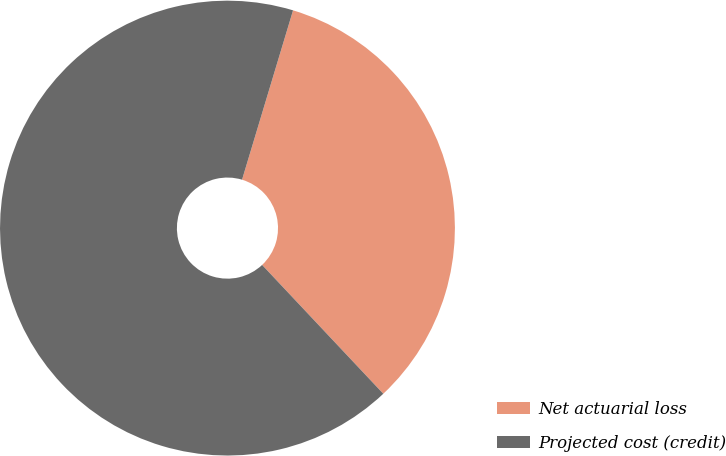Convert chart. <chart><loc_0><loc_0><loc_500><loc_500><pie_chart><fcel>Net actuarial loss<fcel>Projected cost (credit)<nl><fcel>33.33%<fcel>66.67%<nl></chart> 